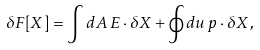<formula> <loc_0><loc_0><loc_500><loc_500>\delta F [ { X } ] = \int d A \, { E } \cdot \delta { X } + \oint d u \, { p } \cdot \delta { X } \, ,</formula> 